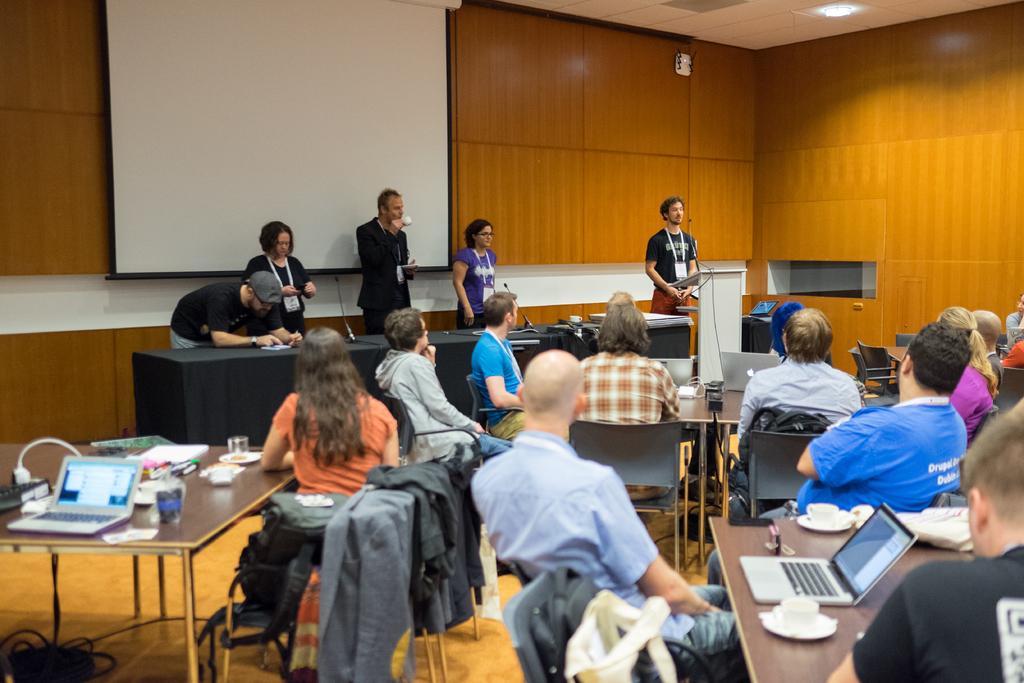Describe this image in one or two sentences. This is a whiteboard on the background. Here we can see persons standing in front of a table on the platform. Here we can see all the persons sitting on chairs in front of tables and on the tables we can see laptops, cups, saucers, glasses, sockets. This is a floor. On the chairs we can see bags , jackets. 